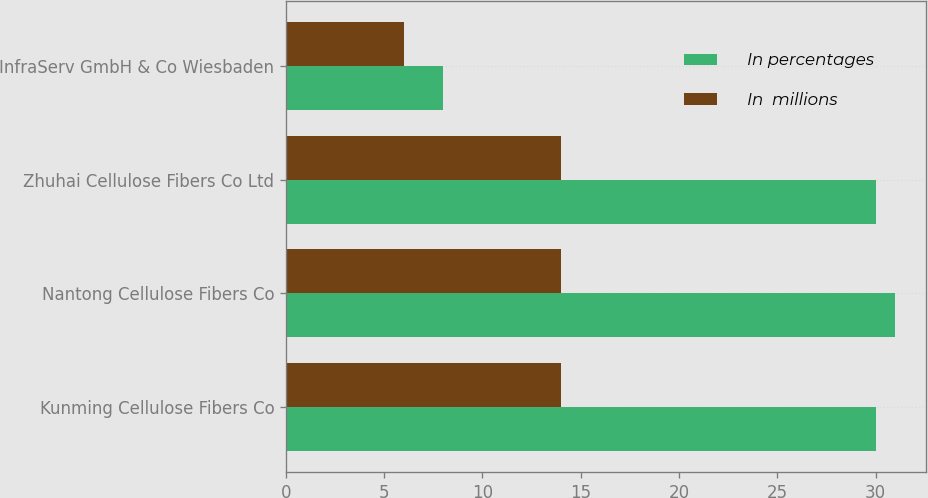Convert chart. <chart><loc_0><loc_0><loc_500><loc_500><stacked_bar_chart><ecel><fcel>Kunming Cellulose Fibers Co<fcel>Nantong Cellulose Fibers Co<fcel>Zhuhai Cellulose Fibers Co Ltd<fcel>InfraServ GmbH & Co Wiesbaden<nl><fcel>In percentages<fcel>30<fcel>31<fcel>30<fcel>8<nl><fcel>In  millions<fcel>14<fcel>14<fcel>14<fcel>6<nl></chart> 